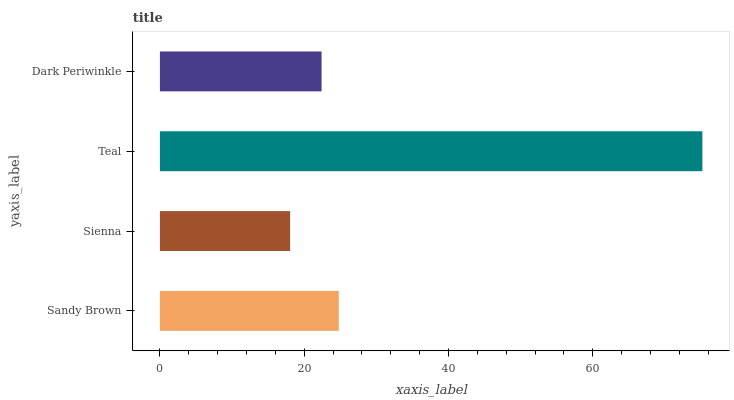Is Sienna the minimum?
Answer yes or no. Yes. Is Teal the maximum?
Answer yes or no. Yes. Is Teal the minimum?
Answer yes or no. No. Is Sienna the maximum?
Answer yes or no. No. Is Teal greater than Sienna?
Answer yes or no. Yes. Is Sienna less than Teal?
Answer yes or no. Yes. Is Sienna greater than Teal?
Answer yes or no. No. Is Teal less than Sienna?
Answer yes or no. No. Is Sandy Brown the high median?
Answer yes or no. Yes. Is Dark Periwinkle the low median?
Answer yes or no. Yes. Is Teal the high median?
Answer yes or no. No. Is Teal the low median?
Answer yes or no. No. 